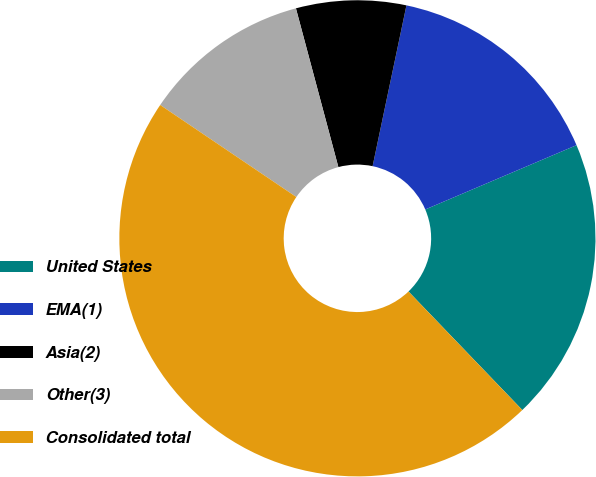Convert chart to OTSL. <chart><loc_0><loc_0><loc_500><loc_500><pie_chart><fcel>United States<fcel>EMA(1)<fcel>Asia(2)<fcel>Other(3)<fcel>Consolidated total<nl><fcel>19.22%<fcel>15.3%<fcel>7.46%<fcel>11.38%<fcel>46.64%<nl></chart> 